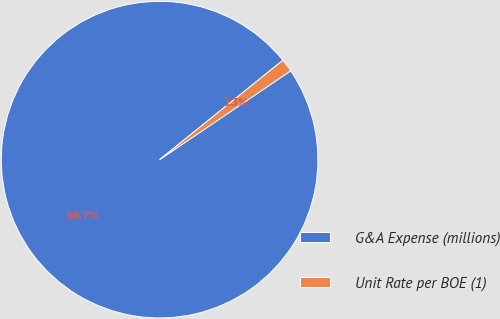<chart> <loc_0><loc_0><loc_500><loc_500><pie_chart><fcel>G&A Expense (millions)<fcel>Unit Rate per BOE (1)<nl><fcel>98.68%<fcel>1.32%<nl></chart> 